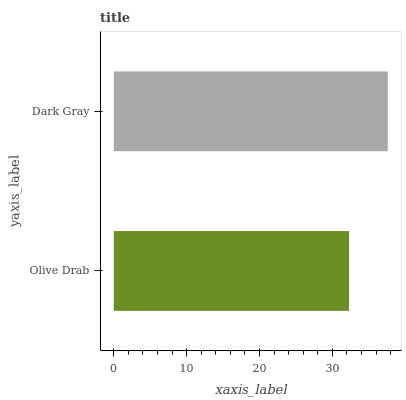Is Olive Drab the minimum?
Answer yes or no. Yes. Is Dark Gray the maximum?
Answer yes or no. Yes. Is Dark Gray the minimum?
Answer yes or no. No. Is Dark Gray greater than Olive Drab?
Answer yes or no. Yes. Is Olive Drab less than Dark Gray?
Answer yes or no. Yes. Is Olive Drab greater than Dark Gray?
Answer yes or no. No. Is Dark Gray less than Olive Drab?
Answer yes or no. No. Is Dark Gray the high median?
Answer yes or no. Yes. Is Olive Drab the low median?
Answer yes or no. Yes. Is Olive Drab the high median?
Answer yes or no. No. Is Dark Gray the low median?
Answer yes or no. No. 